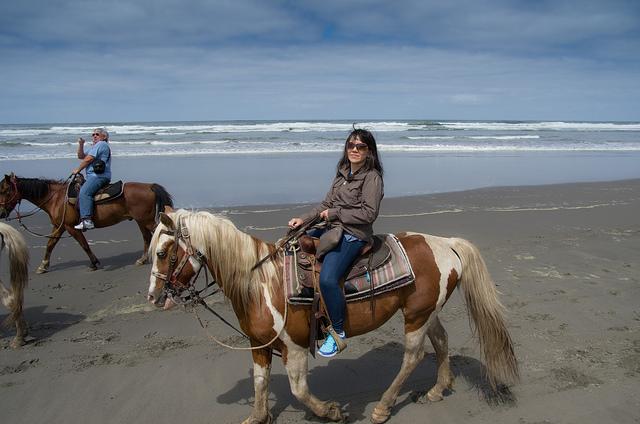Are they in the mountains?
Write a very short answer. No. What color is the girls coat?
Concise answer only. Brown. What are they on?
Be succinct. Horses. Is this a horse show?
Short answer required. No. What surface is being raced on?
Be succinct. Sand. Do they look like they are having fun?
Short answer required. Yes. 